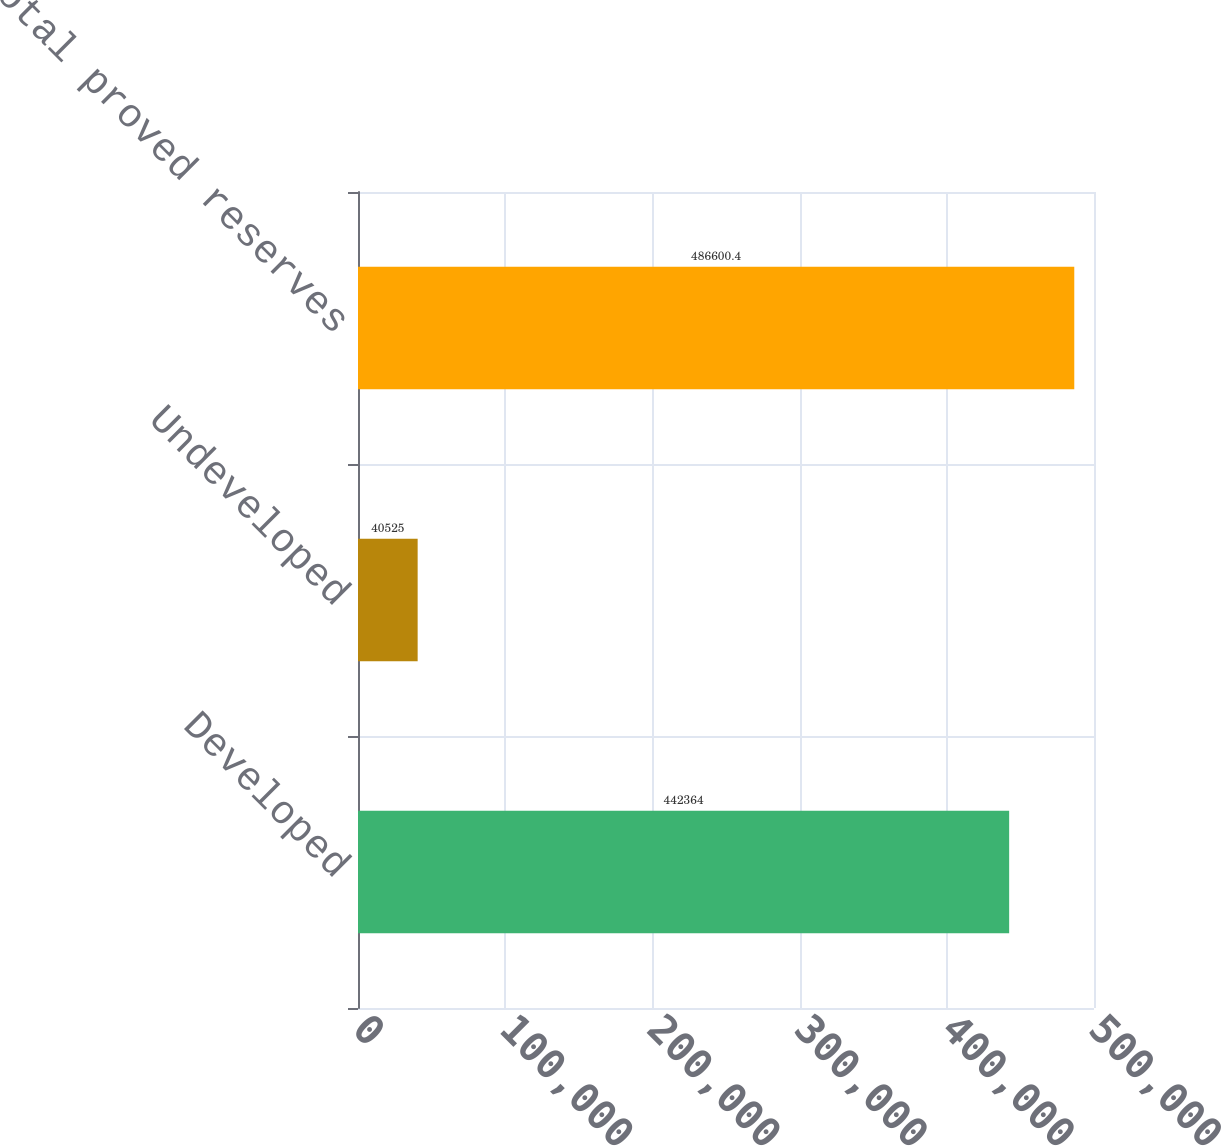<chart> <loc_0><loc_0><loc_500><loc_500><bar_chart><fcel>Developed<fcel>Undeveloped<fcel>Total proved reserves<nl><fcel>442364<fcel>40525<fcel>486600<nl></chart> 